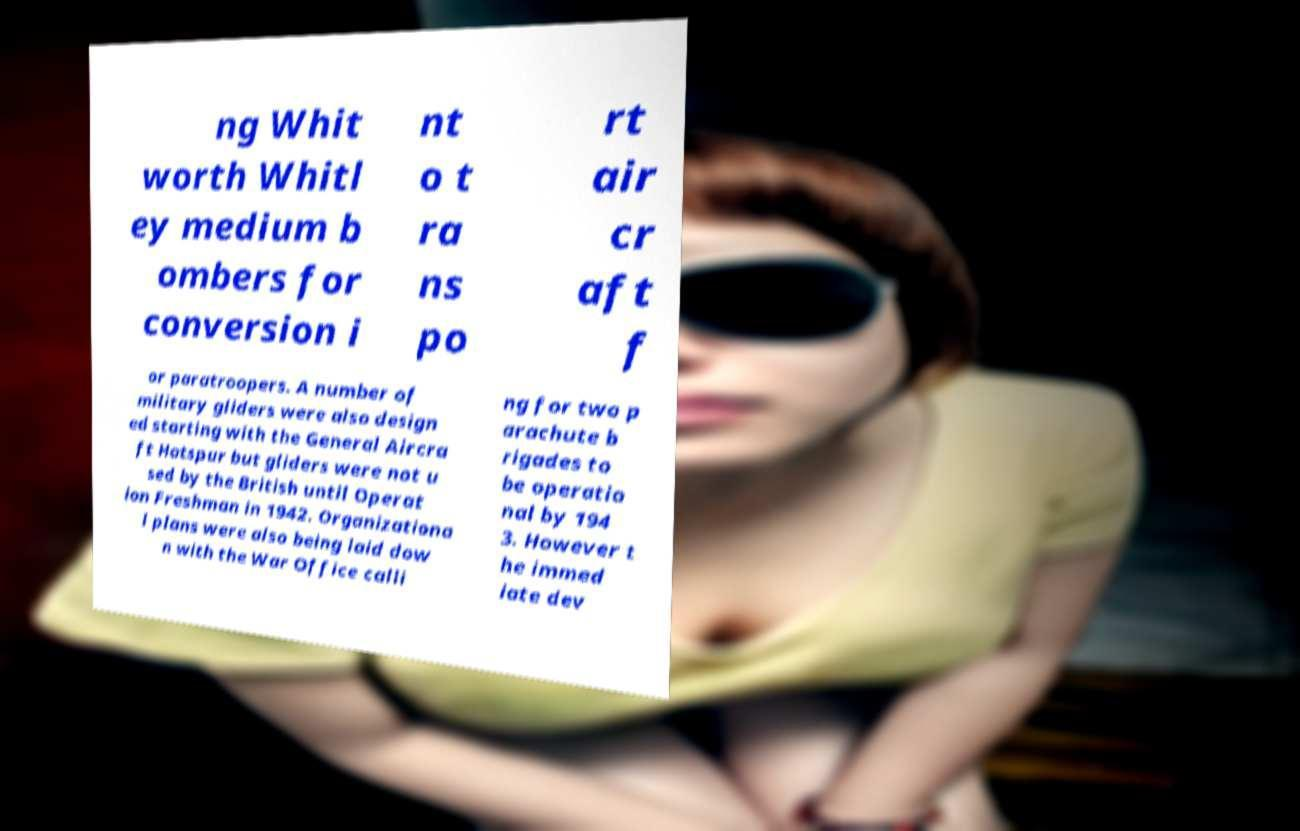For documentation purposes, I need the text within this image transcribed. Could you provide that? ng Whit worth Whitl ey medium b ombers for conversion i nt o t ra ns po rt air cr aft f or paratroopers. A number of military gliders were also design ed starting with the General Aircra ft Hotspur but gliders were not u sed by the British until Operat ion Freshman in 1942. Organizationa l plans were also being laid dow n with the War Office calli ng for two p arachute b rigades to be operatio nal by 194 3. However t he immed iate dev 